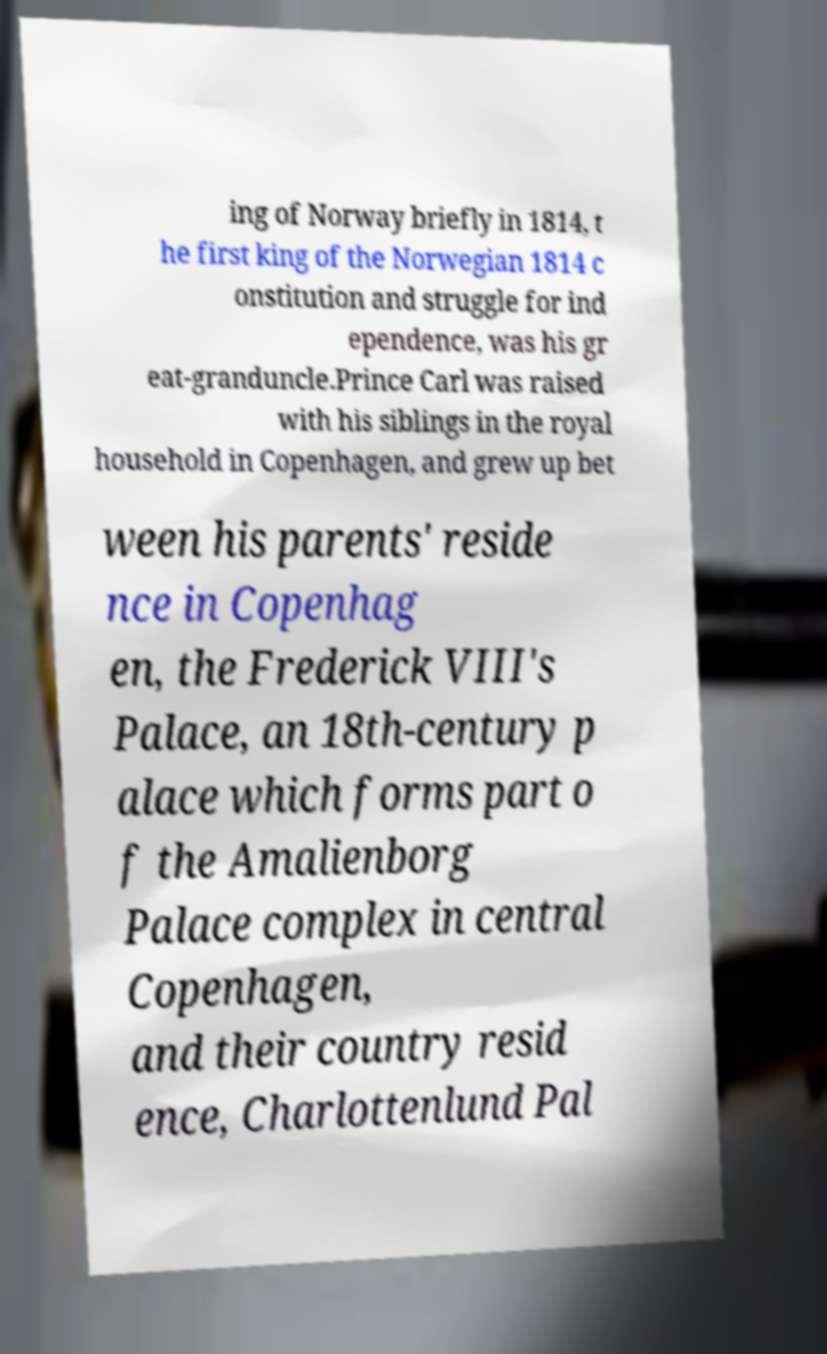For documentation purposes, I need the text within this image transcribed. Could you provide that? ing of Norway briefly in 1814, t he first king of the Norwegian 1814 c onstitution and struggle for ind ependence, was his gr eat-granduncle.Prince Carl was raised with his siblings in the royal household in Copenhagen, and grew up bet ween his parents' reside nce in Copenhag en, the Frederick VIII's Palace, an 18th-century p alace which forms part o f the Amalienborg Palace complex in central Copenhagen, and their country resid ence, Charlottenlund Pal 